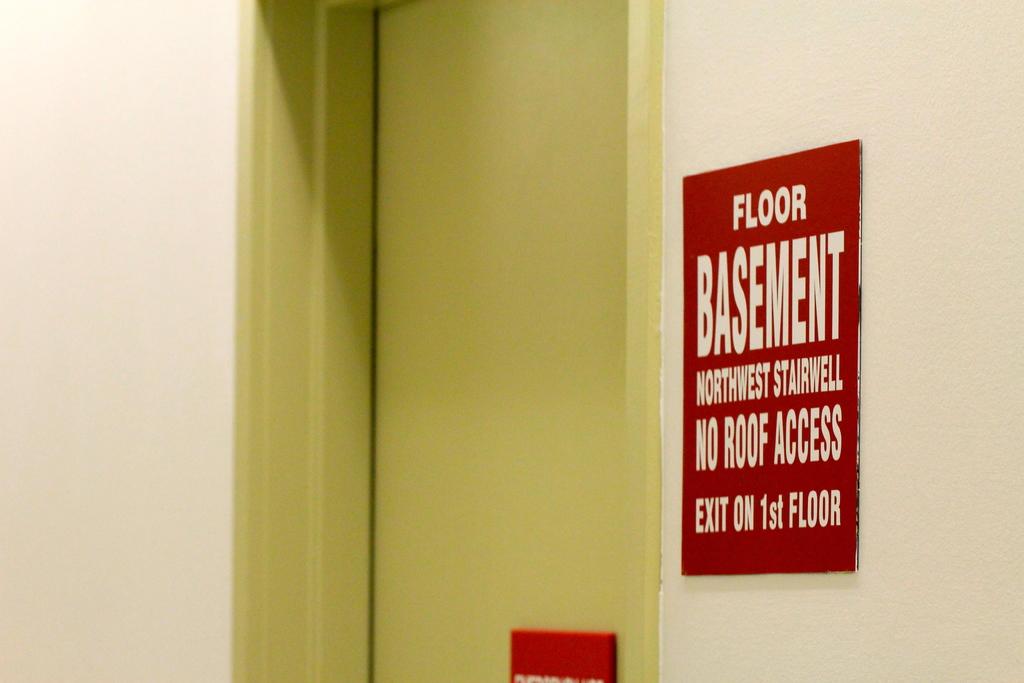What part of the building does this exit not have access to?
Offer a terse response. Roof. What floor is the exit on?
Your answer should be compact. Basement. 